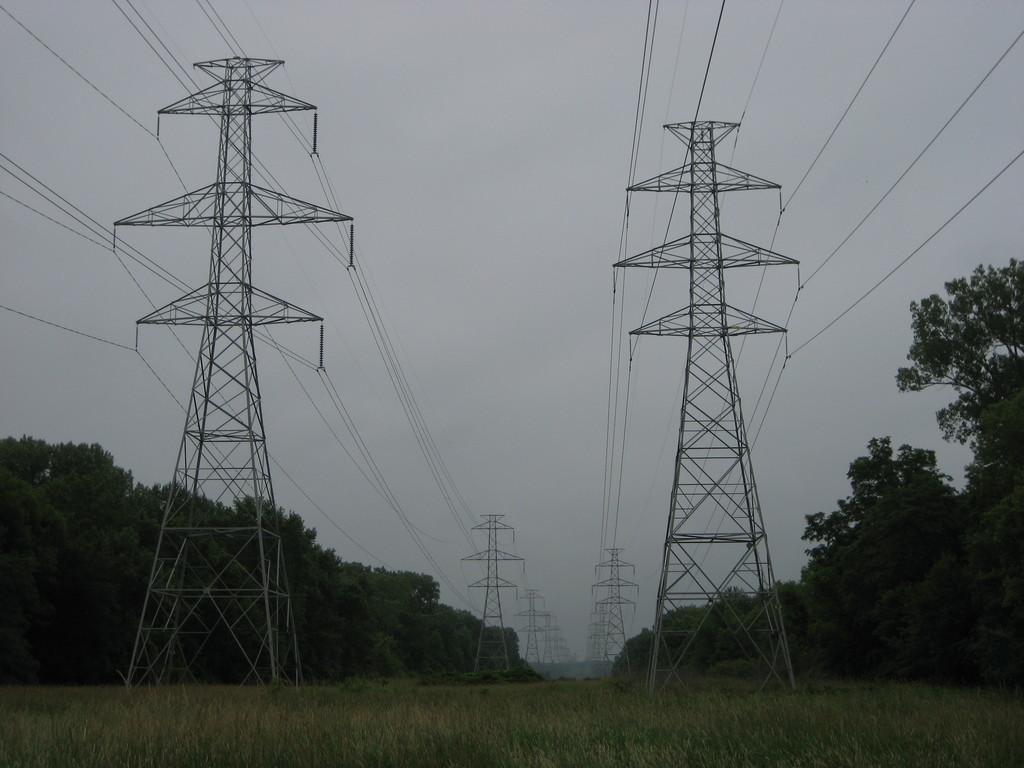Please provide a concise description of this image. In this image I can see the towers with wires. To the side of the towers there are many trees. In the background I can see the sky. 